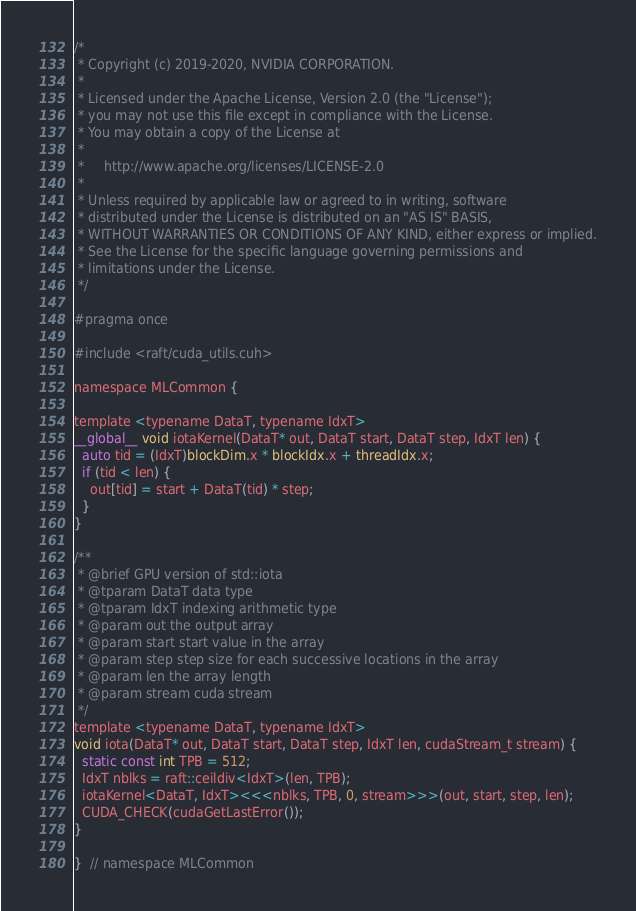Convert code to text. <code><loc_0><loc_0><loc_500><loc_500><_Cuda_>/*
 * Copyright (c) 2019-2020, NVIDIA CORPORATION.
 *
 * Licensed under the Apache License, Version 2.0 (the "License");
 * you may not use this file except in compliance with the License.
 * You may obtain a copy of the License at
 *
 *     http://www.apache.org/licenses/LICENSE-2.0
 *
 * Unless required by applicable law or agreed to in writing, software
 * distributed under the License is distributed on an "AS IS" BASIS,
 * WITHOUT WARRANTIES OR CONDITIONS OF ANY KIND, either express or implied.
 * See the License for the specific language governing permissions and
 * limitations under the License.
 */

#pragma once

#include <raft/cuda_utils.cuh>

namespace MLCommon {

template <typename DataT, typename IdxT>
__global__ void iotaKernel(DataT* out, DataT start, DataT step, IdxT len) {
  auto tid = (IdxT)blockDim.x * blockIdx.x + threadIdx.x;
  if (tid < len) {
    out[tid] = start + DataT(tid) * step;
  }
}

/**
 * @brief GPU version of std::iota
 * @tparam DataT data type
 * @tparam IdxT indexing arithmetic type
 * @param out the output array
 * @param start start value in the array
 * @param step step size for each successive locations in the array
 * @param len the array length
 * @param stream cuda stream
 */
template <typename DataT, typename IdxT>
void iota(DataT* out, DataT start, DataT step, IdxT len, cudaStream_t stream) {
  static const int TPB = 512;
  IdxT nblks = raft::ceildiv<IdxT>(len, TPB);
  iotaKernel<DataT, IdxT><<<nblks, TPB, 0, stream>>>(out, start, step, len);
  CUDA_CHECK(cudaGetLastError());
}

}  // namespace MLCommon
</code> 